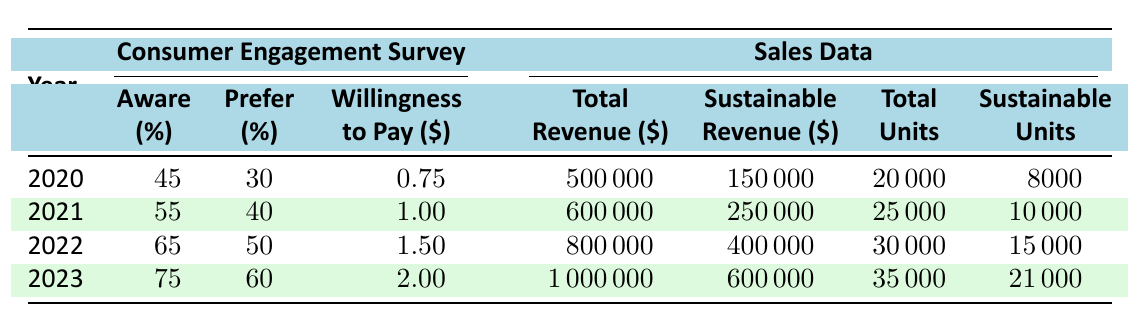What was the percentage of consumers aware of sustainable packaging in 2022? According to the table, the percentage of consumers aware of sustainable packaging in 2022 is provided directly under the "Consumer Engagement Survey" for that year. It shows 65%.
Answer: 65% What is the average increased willingness to pay for sustainable packaging from 2020 to 2023? We take the values from each year (0.75 for 2020, 1.00 for 2021, 1.50 for 2022, and 2.00 for 2023), sum them up (0.75 + 1.00 + 1.50 + 2.00 = 5.25) and divide by the number of years (4). The average is 5.25 / 4 = 1.3125.
Answer: 1.31 Did the total revenue increase from 2020 to 2023? By comparing the total revenue values for the years 2020 and 2023 (500000 for 2020 and 1000000 for 2023), it shows that 1000000 is greater than 500000, hence the total revenue did increase.
Answer: Yes What percentage of total units sold were sustainable packaging products in 2021? The total units sold in 2021 is 25000, and the units sold of sustainable packaging products is 10000. To find the percentage, we calculate (10000 / 25000) * 100, which equals 40%.
Answer: 40% How much revenue was generated from sustainable packaging products in 2023 compared to 2022? The revenue from sustainable packaging products in 2023 is 600000 and for 2022 it's 400000. The difference is calculated as 600000 - 400000 = 200000.
Answer: 200000 What is the total percentage increase in consumers preferring sustainable packaging from 2020 to 2023? The percentage of consumers preferring sustainable packaging in 2020 is 30% and in 2023 it is 60%. The change is calculated as 60 - 30 = 30 percentage points, which is a total percentage increase of 100% since it doubled.
Answer: 100% How many total units sold were there in 2022? The total units sold in 2022 is clearly stated in the "Sales Data" section of the table, which indicates it to be 30000.
Answer: 30000 Did more than 50% of consumers prefer sustainable packaging in 2022? According to the table, in 2022 the percentage of consumers who preferred sustainable packaging is 50%. Since this is not more than 50, the answer is no.
Answer: No 